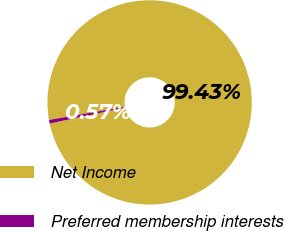Convert chart. <chart><loc_0><loc_0><loc_500><loc_500><pie_chart><fcel>Net Income<fcel>Preferred membership interests<nl><fcel>99.43%<fcel>0.57%<nl></chart> 